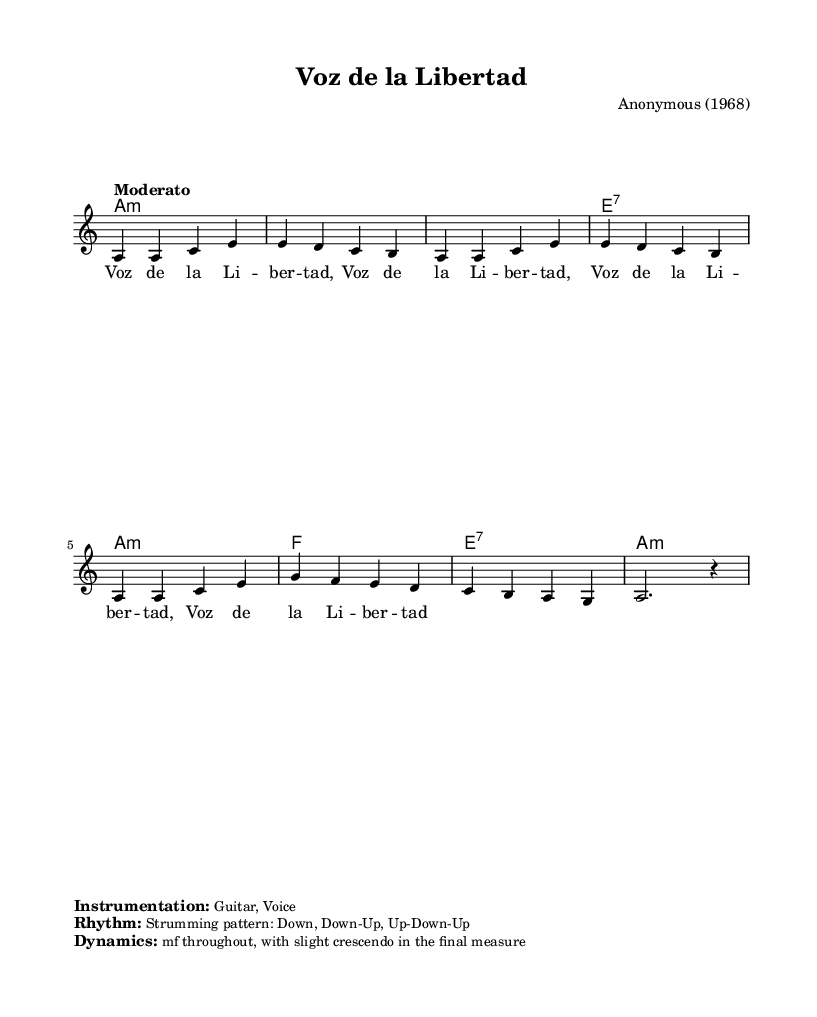What is the key signature of this music? The key signature is A minor, which is indicated by the absence of sharps or flats in the music staff. A minor relative to C major often contains the same notes but centers around A.
Answer: A minor What is the time signature of the piece? The time signature is 4/4, which is shown at the beginning of the score. This means there are four beats in each measure, and each beat is a quarter note.
Answer: 4/4 What is the tempo marking for this piece? The tempo marking is "Moderato," which suggests a moderate pace. It is noted above the staff at the beginning of the score.
Answer: Moderato What is the primary instrumentation used in this piece? The instrumentation listed is Guitar and Voice, mentioned in the markup section under "Instrumentation." This indicates the instruments intended to perform the piece.
Answer: Guitar, Voice How many measures are in this piece? The piece contains 8 measures, which can be counted from the beginning to the end of the melody section in the score. Each group of notes separated by vertical lines represents a measure.
Answer: 8 What is the dynamic marking for this piece? The dynamics are marked as "mf throughout, with slight crescendo in the final measure," indicating a moderately loud volume that increases slightly at the end. This information is provided in the markup section.
Answer: mf What is the strumming pattern indicated for the guitar? The strumming pattern is specified as "Down, Down-Up, Up-Down-Up," which suggests how the guitarist should strum the strings for this piece. This is stated in the markup section under "Rhythm."
Answer: Down, Down-Up, Up-Down-Up 